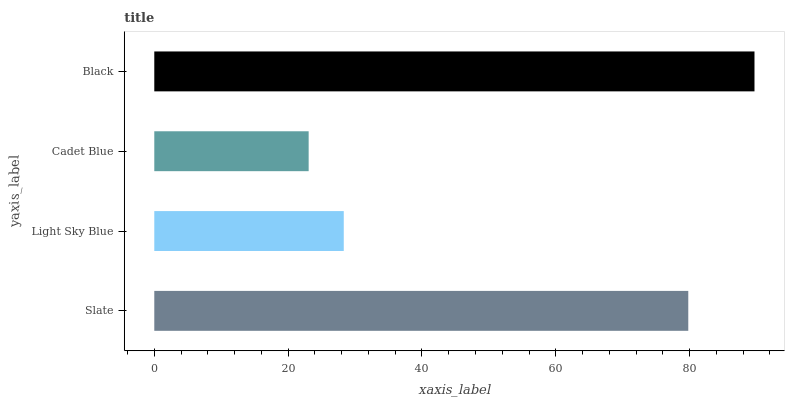Is Cadet Blue the minimum?
Answer yes or no. Yes. Is Black the maximum?
Answer yes or no. Yes. Is Light Sky Blue the minimum?
Answer yes or no. No. Is Light Sky Blue the maximum?
Answer yes or no. No. Is Slate greater than Light Sky Blue?
Answer yes or no. Yes. Is Light Sky Blue less than Slate?
Answer yes or no. Yes. Is Light Sky Blue greater than Slate?
Answer yes or no. No. Is Slate less than Light Sky Blue?
Answer yes or no. No. Is Slate the high median?
Answer yes or no. Yes. Is Light Sky Blue the low median?
Answer yes or no. Yes. Is Black the high median?
Answer yes or no. No. Is Cadet Blue the low median?
Answer yes or no. No. 